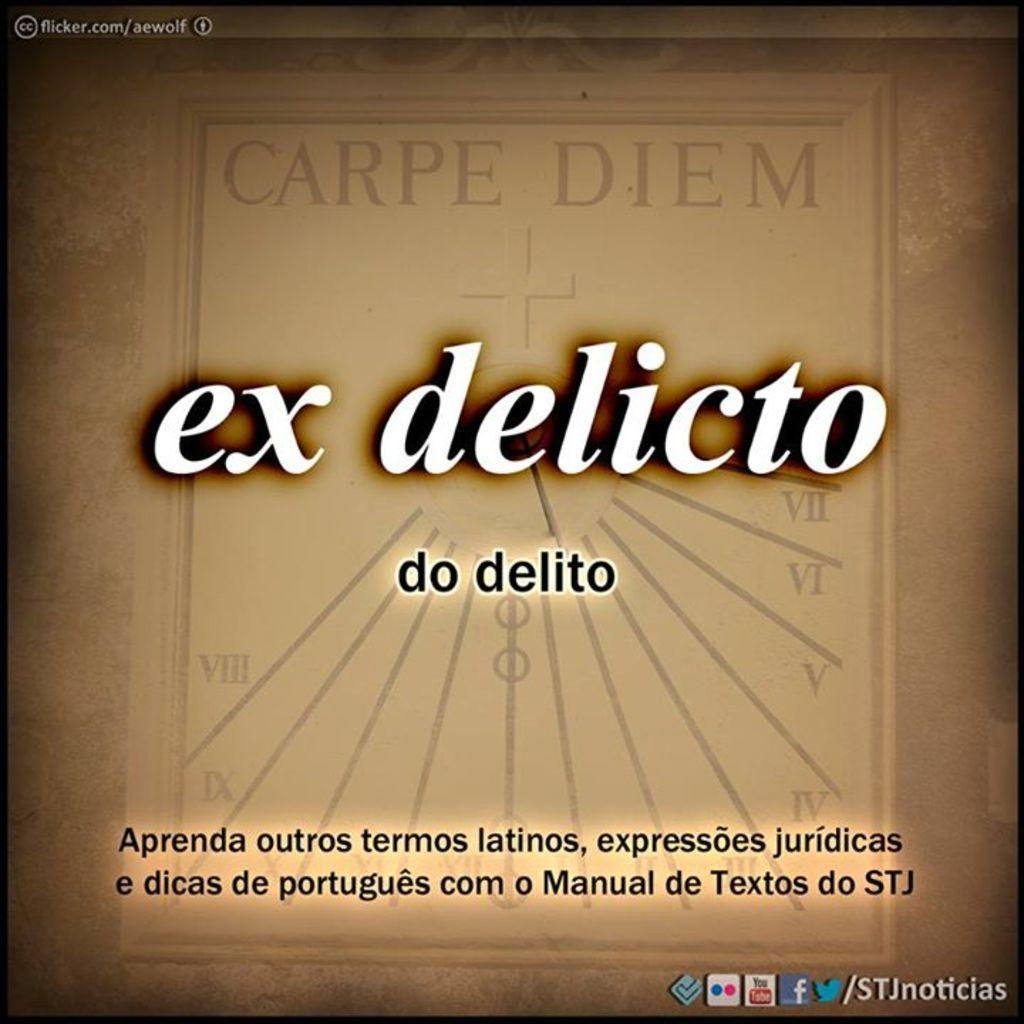Provide a one-sentence caption for the provided image. Ex Delicto written on a tan background with lined designs. 